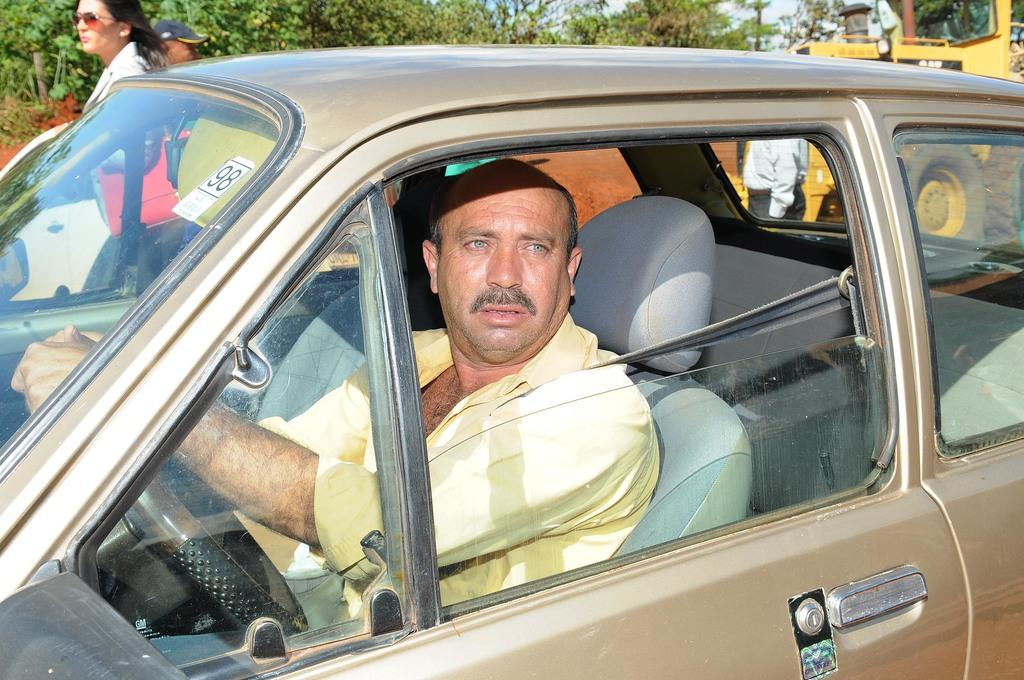What is the person in the image doing? The person is sitting in a car. What color is the shirt the person is wearing? The person is wearing a yellow shirt. What can be seen behind the car? There are other people and a truck behind the car. What type of vegetation is visible in the background? There are trees visible at the back of the scene. What type of bath can be seen in the image? There is no bath present in the image; it features a person sitting in a car with other people and a truck behind it. 